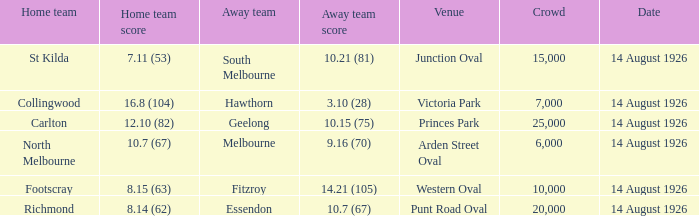What was the typical audience at western oval? 10000.0. 